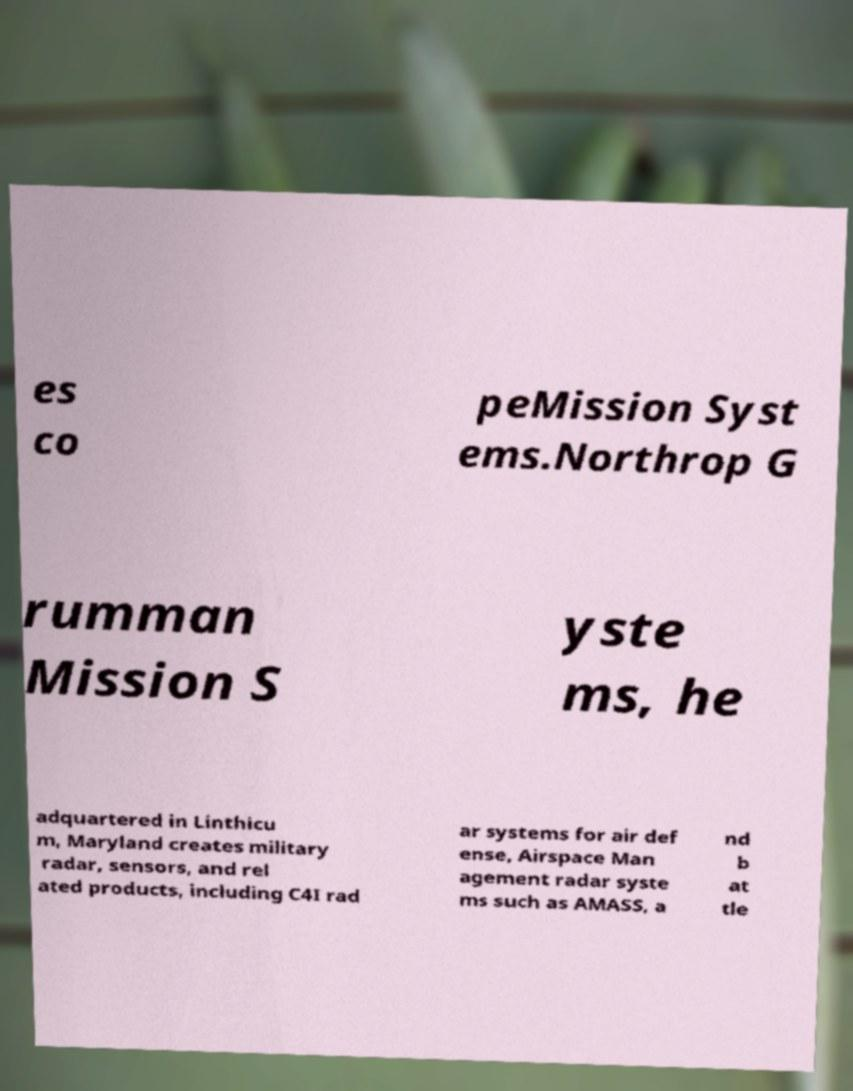I need the written content from this picture converted into text. Can you do that? es co peMission Syst ems.Northrop G rumman Mission S yste ms, he adquartered in Linthicu m, Maryland creates military radar, sensors, and rel ated products, including C4I rad ar systems for air def ense, Airspace Man agement radar syste ms such as AMASS, a nd b at tle 